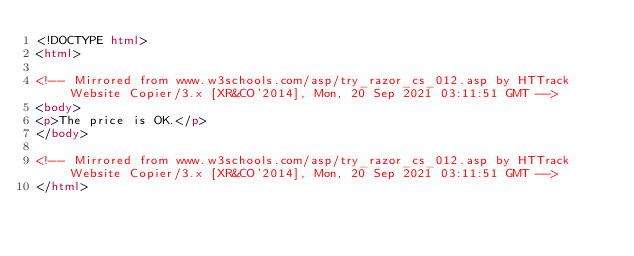Convert code to text. <code><loc_0><loc_0><loc_500><loc_500><_HTML_><!DOCTYPE html>
<html>

<!-- Mirrored from www.w3schools.com/asp/try_razor_cs_012.asp by HTTrack Website Copier/3.x [XR&CO'2014], Mon, 20 Sep 2021 03:11:51 GMT -->
<body>
<p>The price is OK.</p>
</body>

<!-- Mirrored from www.w3schools.com/asp/try_razor_cs_012.asp by HTTrack Website Copier/3.x [XR&CO'2014], Mon, 20 Sep 2021 03:11:51 GMT -->
</html></code> 